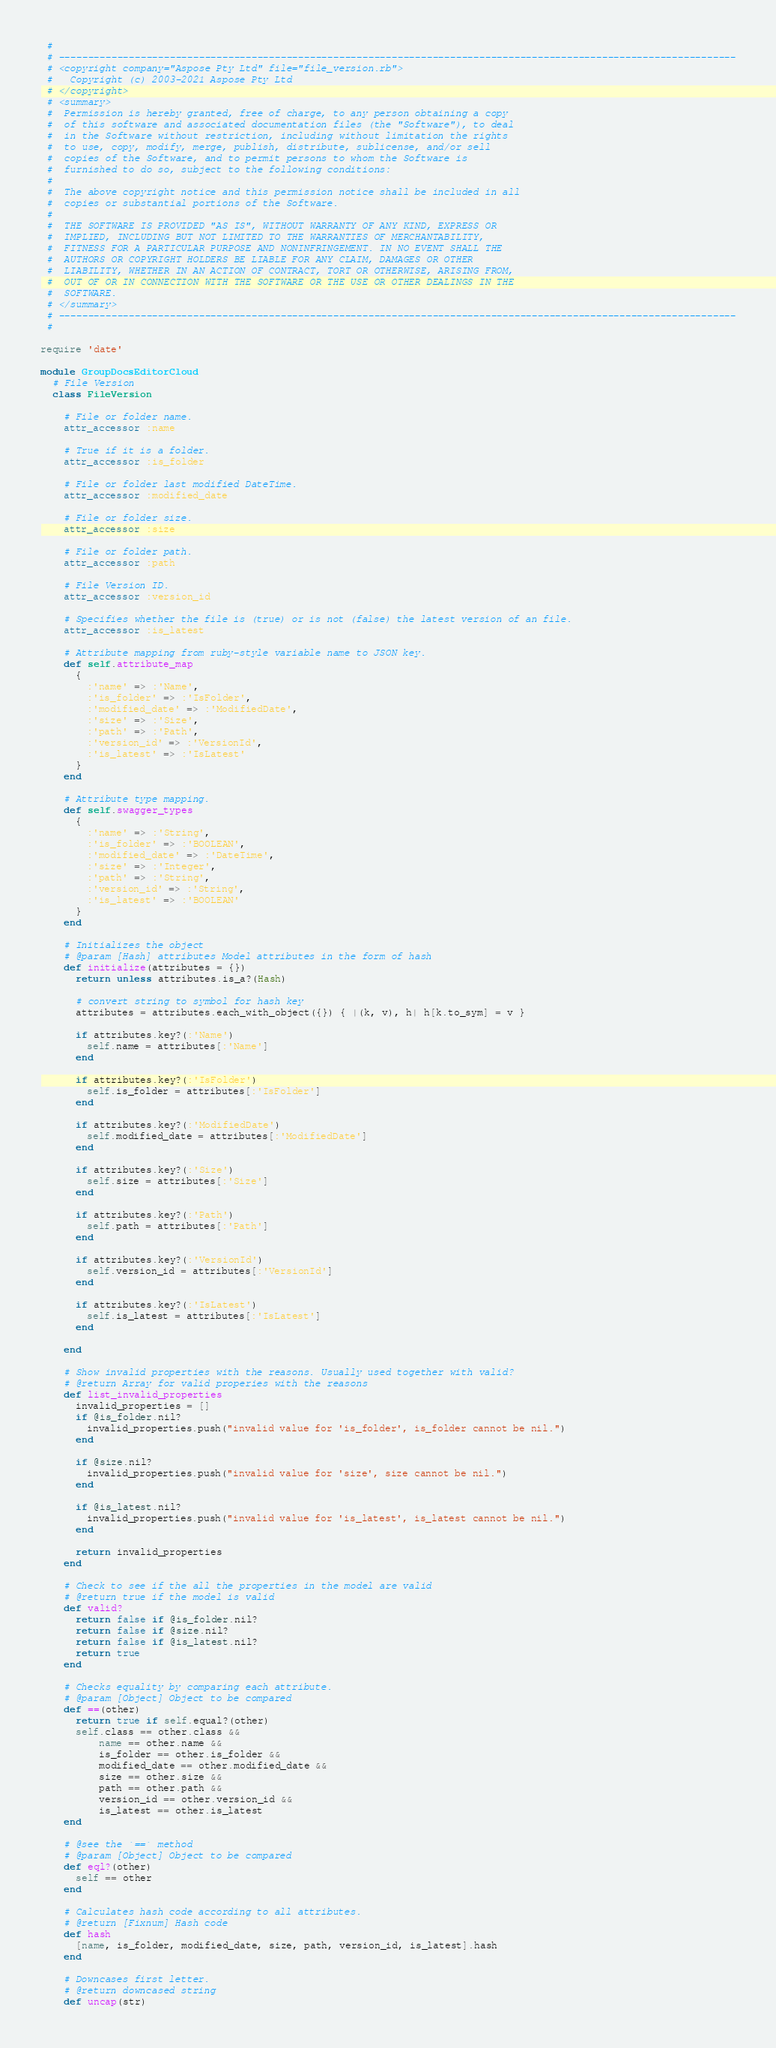<code> <loc_0><loc_0><loc_500><loc_500><_Ruby_> #
 # --------------------------------------------------------------------------------------------------------------------
 # <copyright company="Aspose Pty Ltd" file="file_version.rb">
 #   Copyright (c) 2003-2021 Aspose Pty Ltd
 # </copyright>
 # <summary>
 #  Permission is hereby granted, free of charge, to any person obtaining a copy
 #  of this software and associated documentation files (the "Software"), to deal
 #  in the Software without restriction, including without limitation the rights
 #  to use, copy, modify, merge, publish, distribute, sublicense, and/or sell
 #  copies of the Software, and to permit persons to whom the Software is
 #  furnished to do so, subject to the following conditions:
 #
 #  The above copyright notice and this permission notice shall be included in all
 #  copies or substantial portions of the Software.
 #
 #  THE SOFTWARE IS PROVIDED "AS IS", WITHOUT WARRANTY OF ANY KIND, EXPRESS OR
 #  IMPLIED, INCLUDING BUT NOT LIMITED TO THE WARRANTIES OF MERCHANTABILITY,
 #  FITNESS FOR A PARTICULAR PURPOSE AND NONINFRINGEMENT. IN NO EVENT SHALL THE
 #  AUTHORS OR COPYRIGHT HOLDERS BE LIABLE FOR ANY CLAIM, DAMAGES OR OTHER
 #  LIABILITY, WHETHER IN AN ACTION OF CONTRACT, TORT OR OTHERWISE, ARISING FROM,
 #  OUT OF OR IN CONNECTION WITH THE SOFTWARE OR THE USE OR OTHER DEALINGS IN THE
 #  SOFTWARE.
 # </summary>
 # --------------------------------------------------------------------------------------------------------------------
 #

require 'date'

module GroupDocsEditorCloud
  # File Version
  class FileVersion

    # File or folder name.
    attr_accessor :name

    # True if it is a folder.
    attr_accessor :is_folder

    # File or folder last modified DateTime.
    attr_accessor :modified_date

    # File or folder size.
    attr_accessor :size

    # File or folder path.
    attr_accessor :path

    # File Version ID.
    attr_accessor :version_id

    # Specifies whether the file is (true) or is not (false) the latest version of an file.
    attr_accessor :is_latest

    # Attribute mapping from ruby-style variable name to JSON key.
    def self.attribute_map
      {
        :'name' => :'Name',
        :'is_folder' => :'IsFolder',
        :'modified_date' => :'ModifiedDate',
        :'size' => :'Size',
        :'path' => :'Path',
        :'version_id' => :'VersionId',
        :'is_latest' => :'IsLatest'
      }
    end

    # Attribute type mapping.
    def self.swagger_types
      {
        :'name' => :'String',
        :'is_folder' => :'BOOLEAN',
        :'modified_date' => :'DateTime',
        :'size' => :'Integer',
        :'path' => :'String',
        :'version_id' => :'String',
        :'is_latest' => :'BOOLEAN'
      }
    end

    # Initializes the object
    # @param [Hash] attributes Model attributes in the form of hash
    def initialize(attributes = {})
      return unless attributes.is_a?(Hash)

      # convert string to symbol for hash key
      attributes = attributes.each_with_object({}) { |(k, v), h| h[k.to_sym] = v }

      if attributes.key?(:'Name')
        self.name = attributes[:'Name']
      end

      if attributes.key?(:'IsFolder')
        self.is_folder = attributes[:'IsFolder']
      end

      if attributes.key?(:'ModifiedDate')
        self.modified_date = attributes[:'ModifiedDate']
      end

      if attributes.key?(:'Size')
        self.size = attributes[:'Size']
      end

      if attributes.key?(:'Path')
        self.path = attributes[:'Path']
      end

      if attributes.key?(:'VersionId')
        self.version_id = attributes[:'VersionId']
      end

      if attributes.key?(:'IsLatest')
        self.is_latest = attributes[:'IsLatest']
      end

    end

    # Show invalid properties with the reasons. Usually used together with valid?
    # @return Array for valid properies with the reasons
    def list_invalid_properties
      invalid_properties = []
      if @is_folder.nil?
        invalid_properties.push("invalid value for 'is_folder', is_folder cannot be nil.")
      end

      if @size.nil?
        invalid_properties.push("invalid value for 'size', size cannot be nil.")
      end

      if @is_latest.nil?
        invalid_properties.push("invalid value for 'is_latest', is_latest cannot be nil.")
      end

      return invalid_properties
    end

    # Check to see if the all the properties in the model are valid
    # @return true if the model is valid
    def valid?
      return false if @is_folder.nil?
      return false if @size.nil?
      return false if @is_latest.nil?
      return true
    end

    # Checks equality by comparing each attribute.
    # @param [Object] Object to be compared
    def ==(other)
      return true if self.equal?(other)
      self.class == other.class &&
          name == other.name &&
          is_folder == other.is_folder &&
          modified_date == other.modified_date &&
          size == other.size &&
          path == other.path &&
          version_id == other.version_id &&
          is_latest == other.is_latest
    end

    # @see the `==` method
    # @param [Object] Object to be compared
    def eql?(other)
      self == other
    end

    # Calculates hash code according to all attributes.
    # @return [Fixnum] Hash code
    def hash
      [name, is_folder, modified_date, size, path, version_id, is_latest].hash
    end

    # Downcases first letter.
    # @return downcased string
    def uncap(str)</code> 